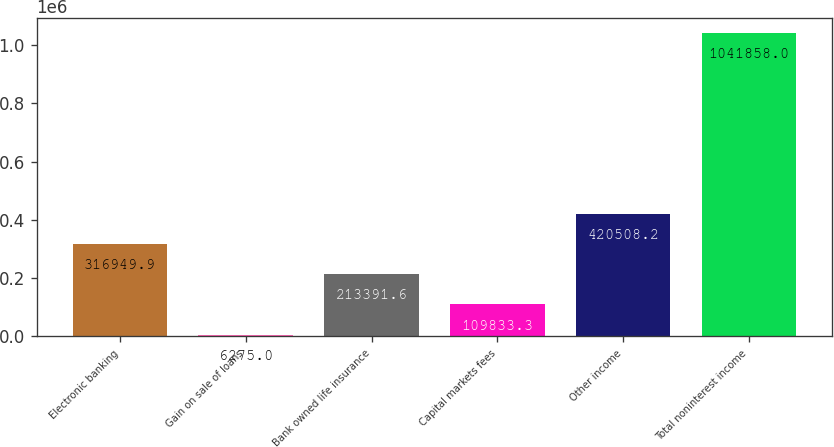<chart> <loc_0><loc_0><loc_500><loc_500><bar_chart><fcel>Electronic banking<fcel>Gain on sale of loans<fcel>Bank owned life insurance<fcel>Capital markets fees<fcel>Other income<fcel>Total noninterest income<nl><fcel>316950<fcel>6275<fcel>213392<fcel>109833<fcel>420508<fcel>1.04186e+06<nl></chart> 